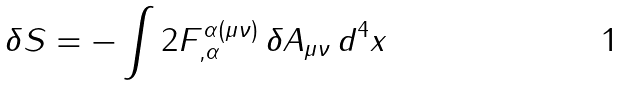<formula> <loc_0><loc_0><loc_500><loc_500>\delta S = - \int 2 F ^ { \alpha ( \mu \nu ) } _ { , \alpha } \, \delta A _ { \mu \nu } \, d ^ { 4 } x</formula> 